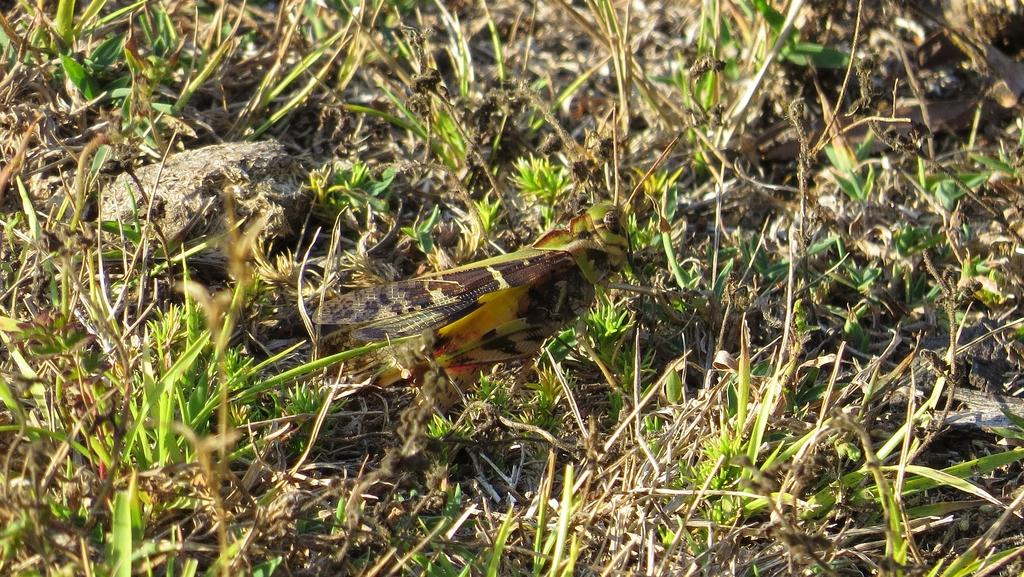What type of creature can be seen in the image? There is an insect in the image. Where is the insect located? The insect is on the grass. How does the insect show respect to the nearby window in the image? There is no window present in the image, and therefore no interaction between the insect and a window can be observed. 